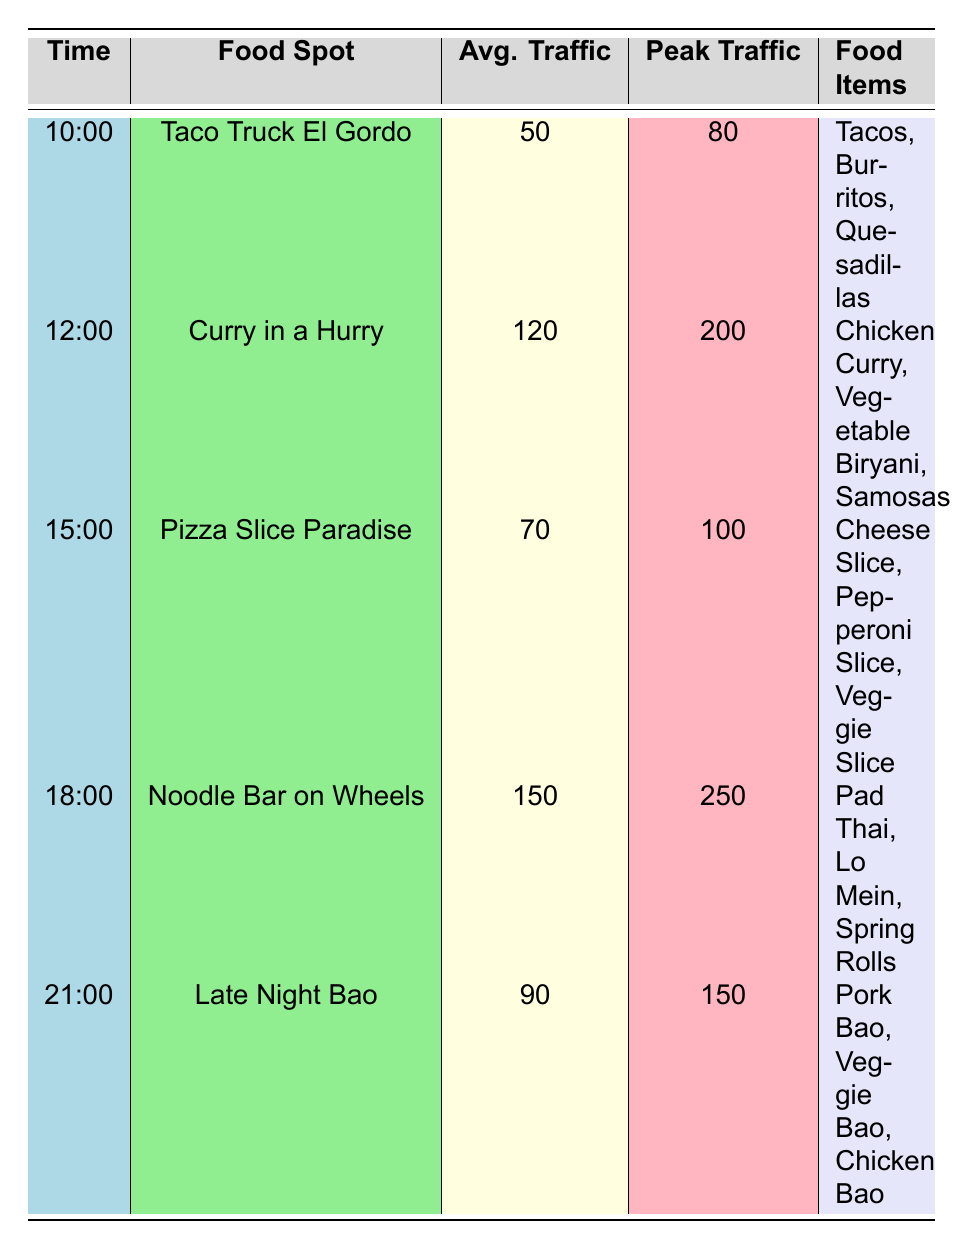What is the average foot traffic for Curry in a Hurry? The table shows that the average foot traffic for Curry in a Hurry at 12:00 is 120.
Answer: 120 What time has the highest peak foot traffic? By examining the peak foot traffic values, we see 250 at 18:00 for Noodle Bar on Wheels, which is the highest.
Answer: 18:00 How many food items are offered at Pizza Slice Paradise? The food items listed for Pizza Slice Paradise are Cheese Slice, Pepperoni Slice, and Veggie Slice, totaling 3 items.
Answer: 3 Is the average foot traffic for Late Night Bao greater than 80? The average foot traffic for Late Night Bao is 90, which is greater than 80.
Answer: Yes What is the total average foot traffic for all food spots listed? To find the total average foot traffic, we sum the individual average foot traffic values: 50 + 120 + 70 + 150 + 90 = 480, and then divide by 5 (the number of food spots) to get the total average. The result is 480 / 5 = 96.
Answer: 96 At what hour is the food spot with the least average foot traffic? The table shows Taco Truck El Gordo at 10:00 has the least average foot traffic, which is 50.
Answer: 10:00 How much greater is the peak foot traffic for Noodle Bar on Wheels compared to Taco Truck El Gordo? The peak traffic for Noodle Bar on Wheels is 250, and for Taco Truck El Gordo, it is 80. The difference is 250 - 80 = 170, making it 170 greater.
Answer: 170 Which food spot offers more food items, Curry in a Hurry or Late Night Bao? Curry in a Hurry has 3 items (Chicken Curry, Vegetable Biryani, Samosas), while Late Night Bao also has 3 items (Pork Bao, Veggie Bao, Chicken Bao), so they are equal.
Answer: Equal What is the average foot traffic for the food spots open after 15:00? The food spots open after 15:00 are Noodle Bar on Wheels and Late Night Bao. Their average foot traffic is 150 and 90 respectively. Adding these gives 150 + 90 = 240 and dividing by 2 gives an average of 120.
Answer: 120 